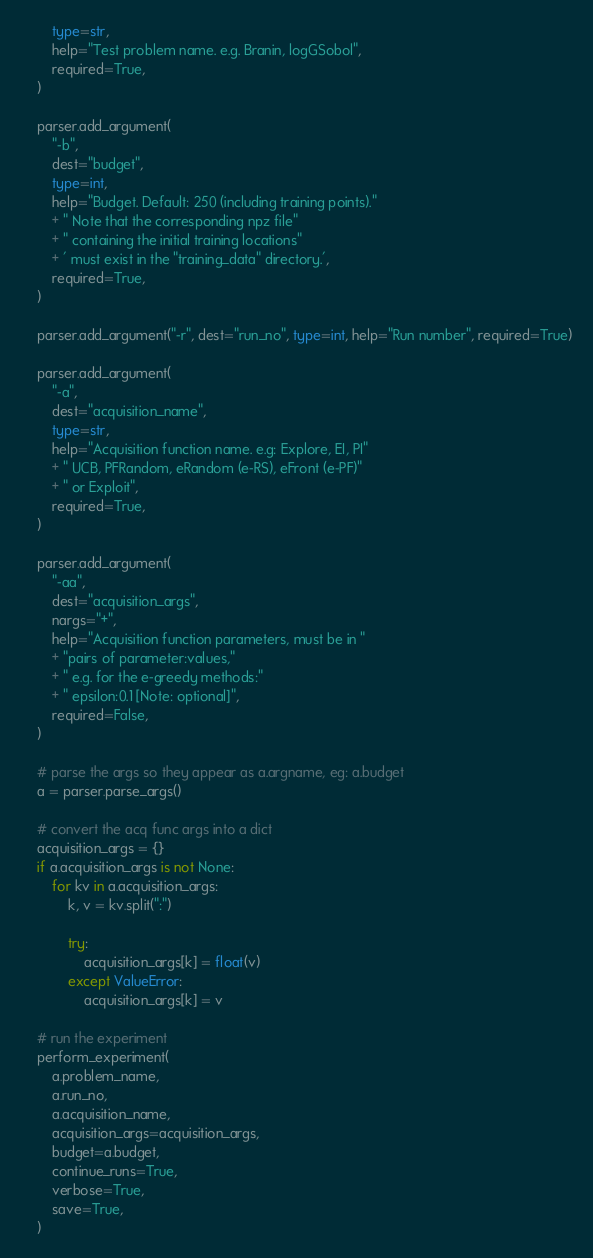Convert code to text. <code><loc_0><loc_0><loc_500><loc_500><_Python_>        type=str,
        help="Test problem name. e.g. Branin, logGSobol",
        required=True,
    )

    parser.add_argument(
        "-b",
        dest="budget",
        type=int,
        help="Budget. Default: 250 (including training points)."
        + " Note that the corresponding npz file"
        + " containing the initial training locations"
        + ' must exist in the "training_data" directory.',
        required=True,
    )

    parser.add_argument("-r", dest="run_no", type=int, help="Run number", required=True)

    parser.add_argument(
        "-a",
        dest="acquisition_name",
        type=str,
        help="Acquisition function name. e.g: Explore, EI, PI"
        + " UCB, PFRandom, eRandom (e-RS), eFront (e-PF)"
        + " or Exploit",
        required=True,
    )

    parser.add_argument(
        "-aa",
        dest="acquisition_args",
        nargs="+",
        help="Acquisition function parameters, must be in "
        + "pairs of parameter:values,"
        + " e.g. for the e-greedy methods:"
        + " epsilon:0.1 [Note: optional]",
        required=False,
    )

    # parse the args so they appear as a.argname, eg: a.budget
    a = parser.parse_args()

    # convert the acq func args into a dict
    acquisition_args = {}
    if a.acquisition_args is not None:
        for kv in a.acquisition_args:
            k, v = kv.split(":")

            try:
                acquisition_args[k] = float(v)
            except ValueError:
                acquisition_args[k] = v

    # run the experiment
    perform_experiment(
        a.problem_name,
        a.run_no,
        a.acquisition_name,
        acquisition_args=acquisition_args,
        budget=a.budget,
        continue_runs=True,
        verbose=True,
        save=True,
    )
</code> 